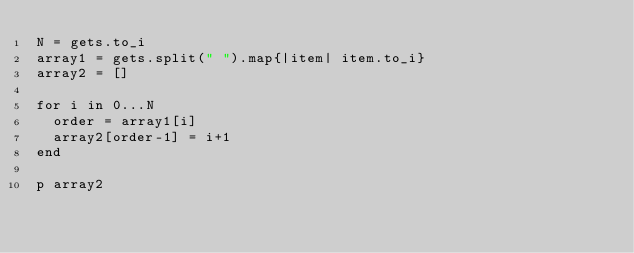<code> <loc_0><loc_0><loc_500><loc_500><_Ruby_>N = gets.to_i
array1 = gets.split(" ").map{|item| item.to_i}
array2 = []

for i in 0...N
  order = array1[i]
  array2[order-1] = i+1
end

p array2</code> 